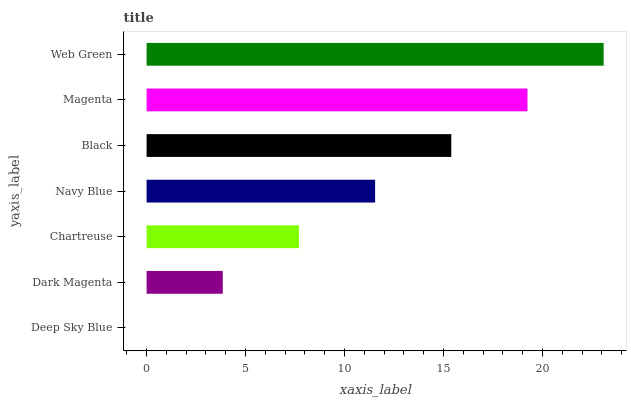Is Deep Sky Blue the minimum?
Answer yes or no. Yes. Is Web Green the maximum?
Answer yes or no. Yes. Is Dark Magenta the minimum?
Answer yes or no. No. Is Dark Magenta the maximum?
Answer yes or no. No. Is Dark Magenta greater than Deep Sky Blue?
Answer yes or no. Yes. Is Deep Sky Blue less than Dark Magenta?
Answer yes or no. Yes. Is Deep Sky Blue greater than Dark Magenta?
Answer yes or no. No. Is Dark Magenta less than Deep Sky Blue?
Answer yes or no. No. Is Navy Blue the high median?
Answer yes or no. Yes. Is Navy Blue the low median?
Answer yes or no. Yes. Is Black the high median?
Answer yes or no. No. Is Magenta the low median?
Answer yes or no. No. 